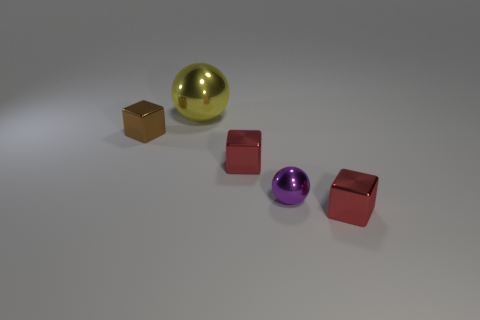There is a small brown block; how many small brown shiny cubes are behind it?
Your answer should be very brief. 0. What is the shape of the red metallic object that is right of the small red metallic object that is behind the tiny metal ball?
Provide a succinct answer. Cube. What shape is the tiny purple thing that is made of the same material as the brown block?
Offer a terse response. Sphere. Is the size of the metal sphere that is behind the small brown object the same as the object that is on the left side of the yellow shiny thing?
Keep it short and to the point. No. There is a tiny thing that is to the left of the big object; what shape is it?
Provide a short and direct response. Cube. What color is the large sphere?
Your answer should be very brief. Yellow. There is a brown metallic thing; is it the same size as the metal object that is on the right side of the small purple ball?
Keep it short and to the point. Yes. How many rubber things are yellow spheres or brown objects?
Ensure brevity in your answer.  0. What is the shape of the yellow object?
Make the answer very short. Sphere. There is a metallic sphere that is behind the brown cube that is behind the shiny sphere that is on the right side of the yellow sphere; what size is it?
Your answer should be compact. Large. 